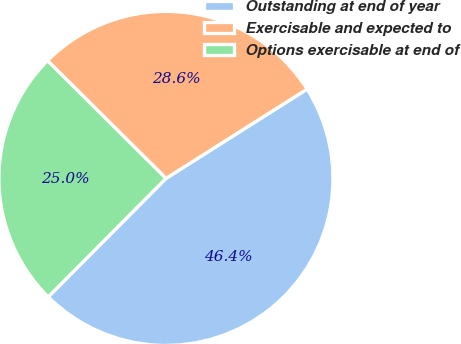Convert chart. <chart><loc_0><loc_0><loc_500><loc_500><pie_chart><fcel>Outstanding at end of year<fcel>Exercisable and expected to<fcel>Options exercisable at end of<nl><fcel>46.43%<fcel>28.57%<fcel>25.0%<nl></chart> 